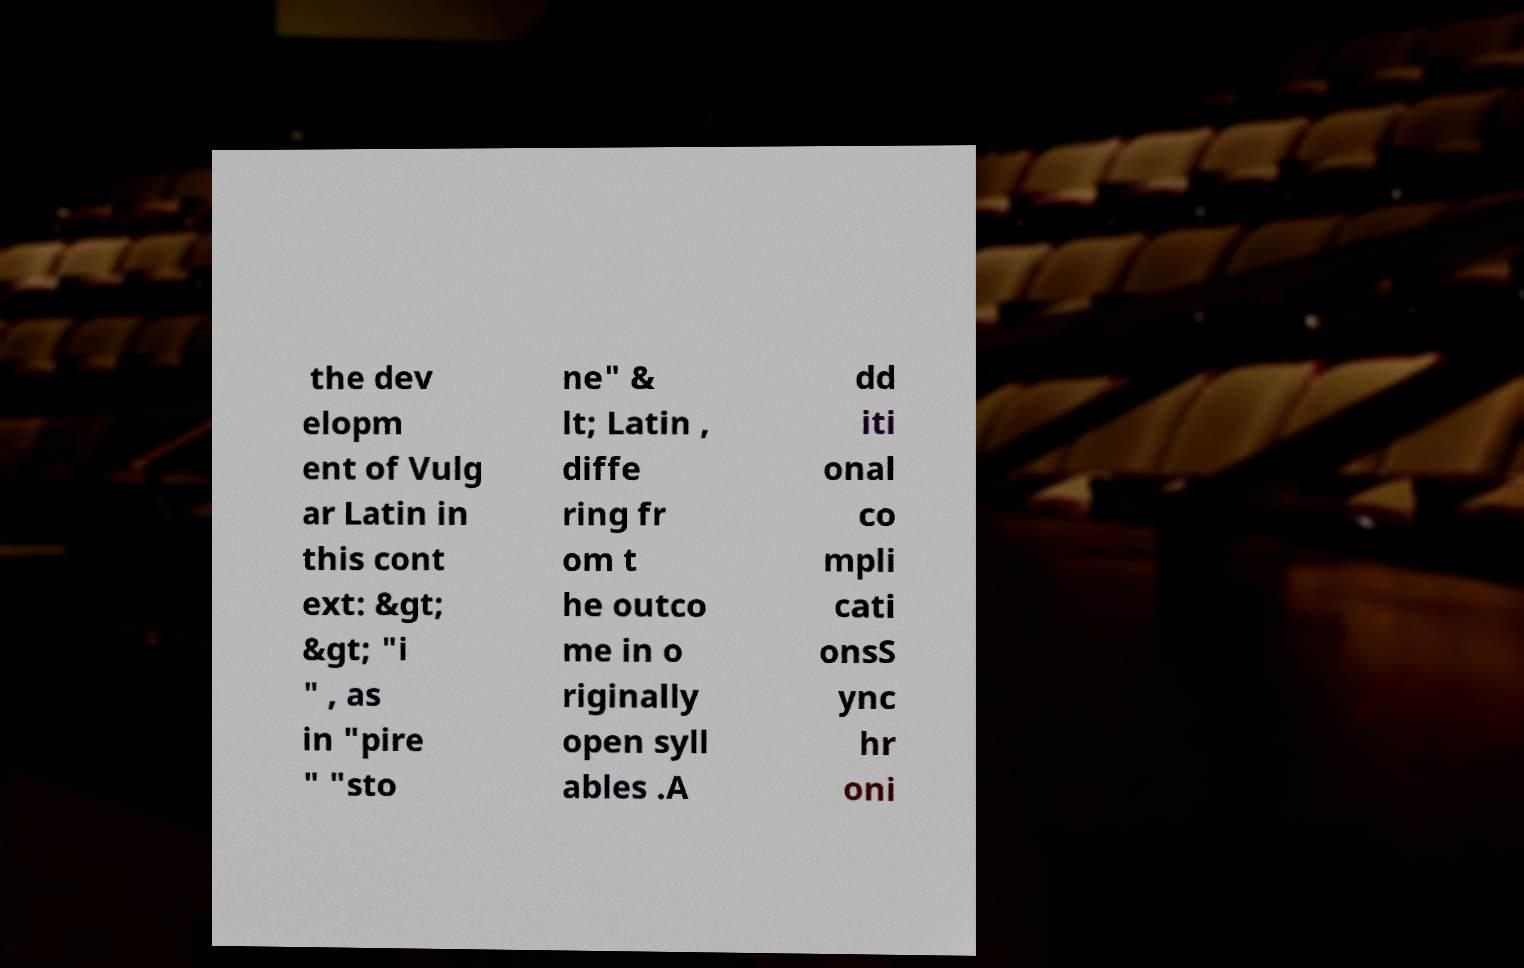Can you read and provide the text displayed in the image?This photo seems to have some interesting text. Can you extract and type it out for me? the dev elopm ent of Vulg ar Latin in this cont ext: &gt; &gt; "i " , as in "pire " "sto ne" & lt; Latin , diffe ring fr om t he outco me in o riginally open syll ables .A dd iti onal co mpli cati onsS ync hr oni 